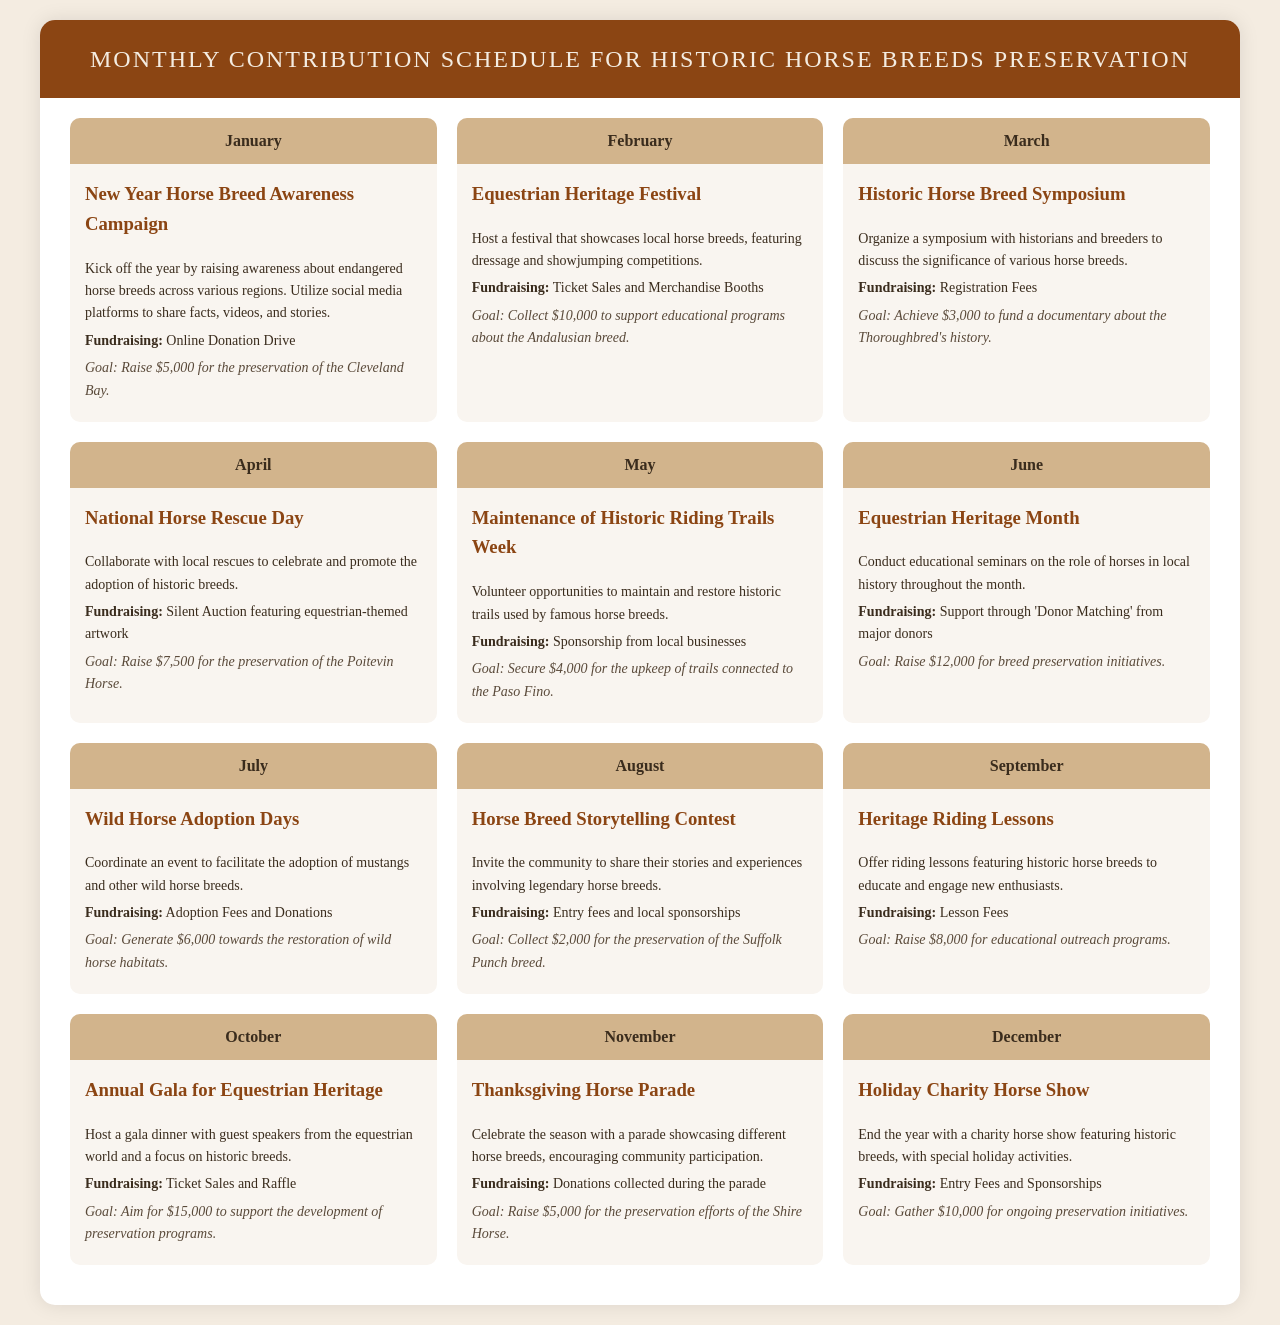What is the goal for January? The goal for January is specified in the monthly schedule, which indicates the amount aimed for preservation efforts.
Answer: Raise $5,000 for the preservation of the Cleveland Bay What event is scheduled for October? The event scheduled for October is detailed in the document, mentioning its name and purpose.
Answer: Annual Gala for Equestrian Heritage How much fundraising is aimed for June? The document provides the fundraising goal for June, detailing the financial target.
Answer: $12,000 Which horse breed is featured in November? The document specifically names the horse breed associated with the November event, crucial for preservation efforts.
Answer: Shire Horse What fundraising method is used for the August event? The document outlines the fundraising strategies for each event, identifying those used in August.
Answer: Entry fees and local sponsorships What is the total target amount for October? To understand the financial goals for that month, the document states the specific amount to be raised for preservation programs.
Answer: $15,000 Which activity takes place in March? The document lists the events scheduled for March, including their purpose and details.
Answer: Historic Horse Breed Symposium Which month features the Equestrian Heritage Festival? The month associated with this specific event is explicitly stated in the schedule.
Answer: February What is the fundraising goal for the December event? The document specifies the financial target for December's charity event, important for preservation initiatives.
Answer: $10,000 